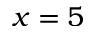Convert formula to latex. <formula><loc_0><loc_0><loc_500><loc_500>x = 5</formula> 